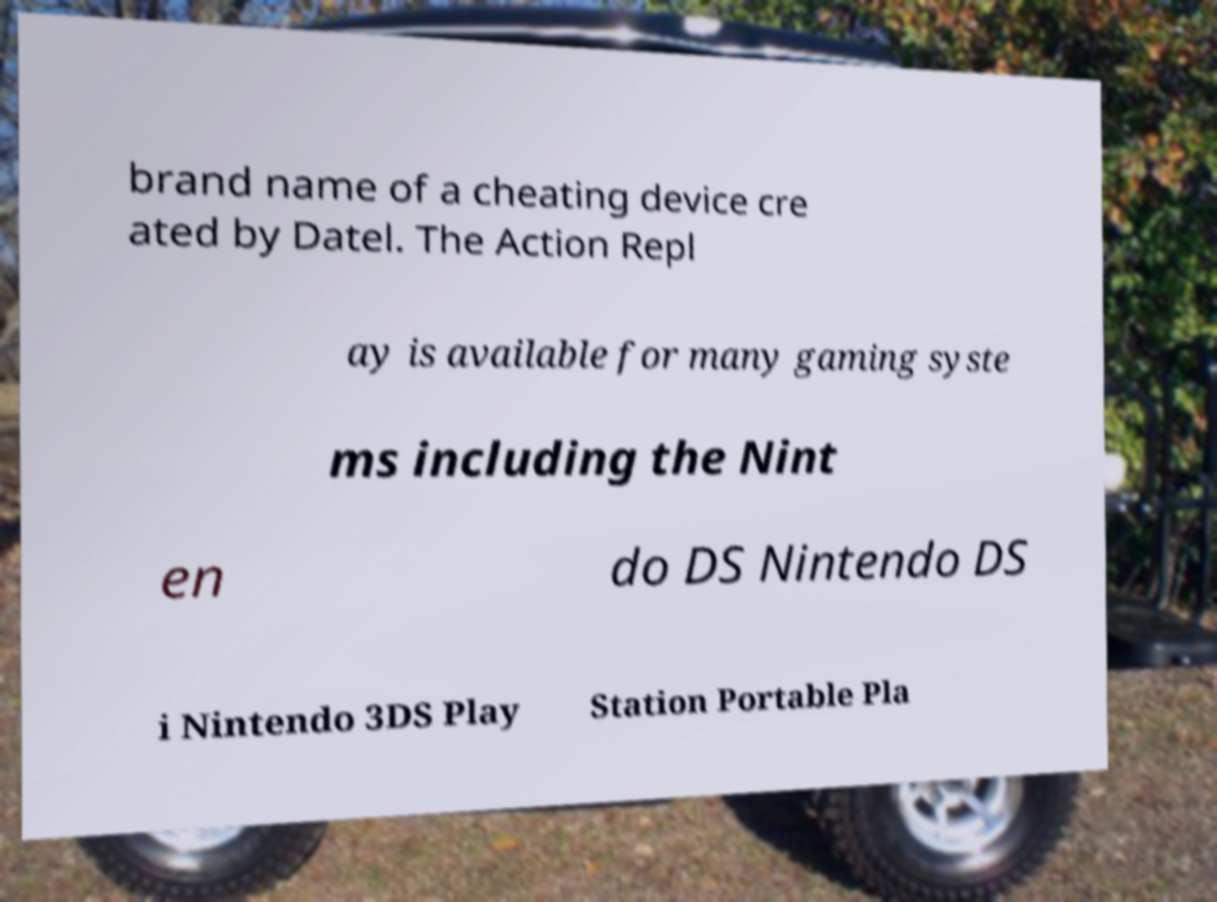Please identify and transcribe the text found in this image. brand name of a cheating device cre ated by Datel. The Action Repl ay is available for many gaming syste ms including the Nint en do DS Nintendo DS i Nintendo 3DS Play Station Portable Pla 